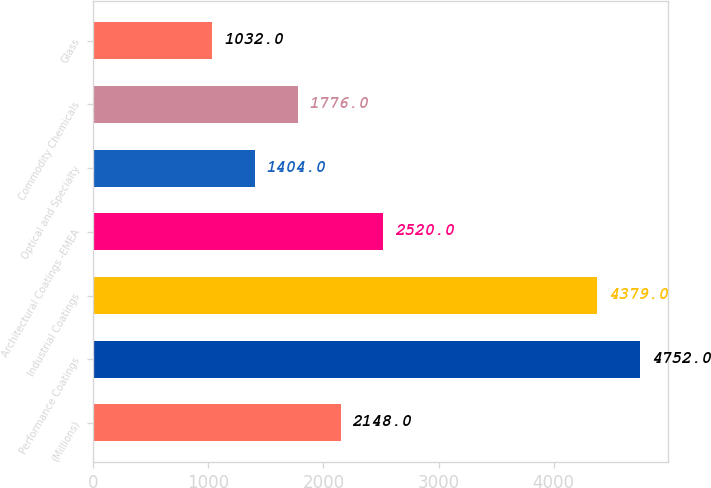Convert chart to OTSL. <chart><loc_0><loc_0><loc_500><loc_500><bar_chart><fcel>(Millions)<fcel>Performance Coatings<fcel>Industrial Coatings<fcel>Architectural Coatings -EMEA<fcel>Optical and Specialty<fcel>Commodity Chemicals<fcel>Glass<nl><fcel>2148<fcel>4752<fcel>4379<fcel>2520<fcel>1404<fcel>1776<fcel>1032<nl></chart> 